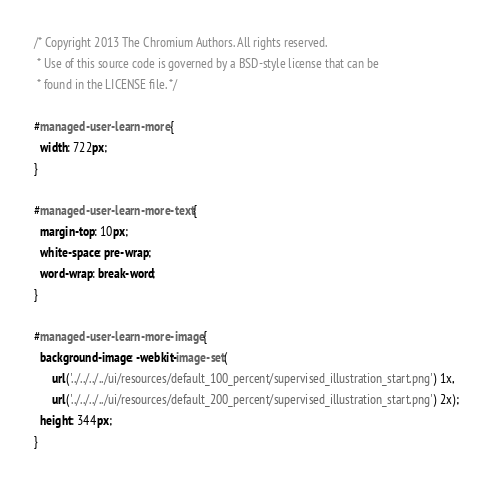Convert code to text. <code><loc_0><loc_0><loc_500><loc_500><_CSS_>/* Copyright 2013 The Chromium Authors. All rights reserved.
 * Use of this source code is governed by a BSD-style license that can be
 * found in the LICENSE file. */

#managed-user-learn-more {
  width: 722px;
}

#managed-user-learn-more-text {
  margin-top: 10px;
  white-space: pre-wrap;
  word-wrap: break-word;
}

#managed-user-learn-more-image {
  background-image: -webkit-image-set(
      url('../../../../ui/resources/default_100_percent/supervised_illustration_start.png') 1x,
      url('../../../../ui/resources/default_200_percent/supervised_illustration_start.png') 2x);
  height: 344px;
}
</code> 